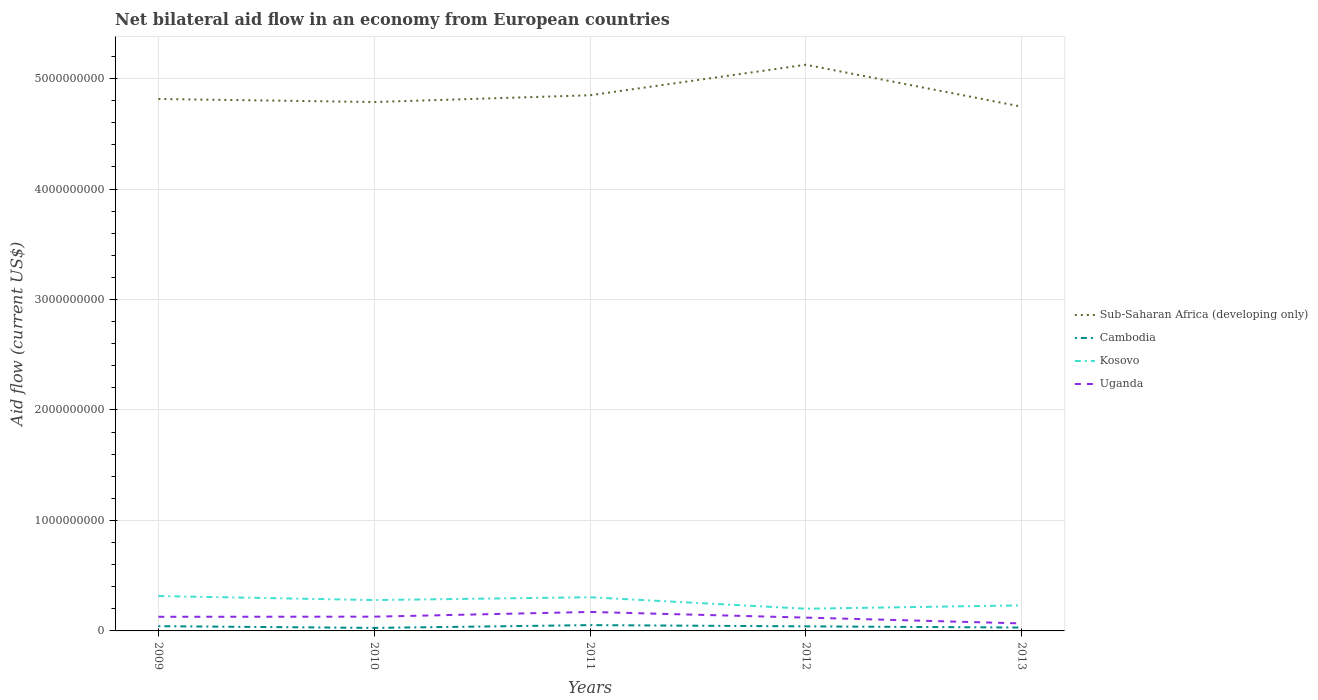Does the line corresponding to Sub-Saharan Africa (developing only) intersect with the line corresponding to Cambodia?
Your response must be concise. No. Across all years, what is the maximum net bilateral aid flow in Sub-Saharan Africa (developing only)?
Ensure brevity in your answer.  4.75e+09. In which year was the net bilateral aid flow in Uganda maximum?
Your response must be concise. 2013. What is the total net bilateral aid flow in Uganda in the graph?
Your answer should be compact. 1.04e+08. What is the difference between the highest and the second highest net bilateral aid flow in Uganda?
Provide a short and direct response. 1.04e+08. What is the difference between the highest and the lowest net bilateral aid flow in Kosovo?
Ensure brevity in your answer.  3. Is the net bilateral aid flow in Sub-Saharan Africa (developing only) strictly greater than the net bilateral aid flow in Kosovo over the years?
Your answer should be very brief. No. How many lines are there?
Your response must be concise. 4. What is the difference between two consecutive major ticks on the Y-axis?
Offer a terse response. 1.00e+09. Does the graph contain grids?
Ensure brevity in your answer.  Yes. Where does the legend appear in the graph?
Offer a terse response. Center right. How many legend labels are there?
Keep it short and to the point. 4. What is the title of the graph?
Your answer should be very brief. Net bilateral aid flow in an economy from European countries. What is the Aid flow (current US$) in Sub-Saharan Africa (developing only) in 2009?
Ensure brevity in your answer.  4.82e+09. What is the Aid flow (current US$) in Cambodia in 2009?
Your answer should be very brief. 4.31e+07. What is the Aid flow (current US$) in Kosovo in 2009?
Offer a terse response. 3.16e+08. What is the Aid flow (current US$) in Uganda in 2009?
Your answer should be very brief. 1.28e+08. What is the Aid flow (current US$) of Sub-Saharan Africa (developing only) in 2010?
Provide a succinct answer. 4.79e+09. What is the Aid flow (current US$) in Cambodia in 2010?
Your answer should be compact. 2.73e+07. What is the Aid flow (current US$) in Kosovo in 2010?
Your response must be concise. 2.79e+08. What is the Aid flow (current US$) in Uganda in 2010?
Keep it short and to the point. 1.29e+08. What is the Aid flow (current US$) in Sub-Saharan Africa (developing only) in 2011?
Your answer should be very brief. 4.85e+09. What is the Aid flow (current US$) of Cambodia in 2011?
Provide a succinct answer. 5.26e+07. What is the Aid flow (current US$) in Kosovo in 2011?
Offer a very short reply. 3.05e+08. What is the Aid flow (current US$) of Uganda in 2011?
Keep it short and to the point. 1.72e+08. What is the Aid flow (current US$) in Sub-Saharan Africa (developing only) in 2012?
Make the answer very short. 5.13e+09. What is the Aid flow (current US$) of Cambodia in 2012?
Your response must be concise. 4.14e+07. What is the Aid flow (current US$) of Kosovo in 2012?
Provide a succinct answer. 2.01e+08. What is the Aid flow (current US$) in Uganda in 2012?
Give a very brief answer. 1.21e+08. What is the Aid flow (current US$) in Sub-Saharan Africa (developing only) in 2013?
Offer a terse response. 4.75e+09. What is the Aid flow (current US$) of Cambodia in 2013?
Ensure brevity in your answer.  3.06e+07. What is the Aid flow (current US$) of Kosovo in 2013?
Your answer should be very brief. 2.31e+08. What is the Aid flow (current US$) of Uganda in 2013?
Provide a succinct answer. 6.80e+07. Across all years, what is the maximum Aid flow (current US$) in Sub-Saharan Africa (developing only)?
Offer a very short reply. 5.13e+09. Across all years, what is the maximum Aid flow (current US$) in Cambodia?
Make the answer very short. 5.26e+07. Across all years, what is the maximum Aid flow (current US$) in Kosovo?
Give a very brief answer. 3.16e+08. Across all years, what is the maximum Aid flow (current US$) of Uganda?
Give a very brief answer. 1.72e+08. Across all years, what is the minimum Aid flow (current US$) in Sub-Saharan Africa (developing only)?
Make the answer very short. 4.75e+09. Across all years, what is the minimum Aid flow (current US$) in Cambodia?
Offer a very short reply. 2.73e+07. Across all years, what is the minimum Aid flow (current US$) in Kosovo?
Offer a very short reply. 2.01e+08. Across all years, what is the minimum Aid flow (current US$) of Uganda?
Offer a very short reply. 6.80e+07. What is the total Aid flow (current US$) of Sub-Saharan Africa (developing only) in the graph?
Give a very brief answer. 2.43e+1. What is the total Aid flow (current US$) of Cambodia in the graph?
Your response must be concise. 1.95e+08. What is the total Aid flow (current US$) of Kosovo in the graph?
Keep it short and to the point. 1.33e+09. What is the total Aid flow (current US$) in Uganda in the graph?
Give a very brief answer. 6.17e+08. What is the difference between the Aid flow (current US$) in Sub-Saharan Africa (developing only) in 2009 and that in 2010?
Provide a succinct answer. 2.76e+07. What is the difference between the Aid flow (current US$) of Cambodia in 2009 and that in 2010?
Offer a terse response. 1.58e+07. What is the difference between the Aid flow (current US$) of Kosovo in 2009 and that in 2010?
Your response must be concise. 3.66e+07. What is the difference between the Aid flow (current US$) in Uganda in 2009 and that in 2010?
Your response must be concise. -9.00e+05. What is the difference between the Aid flow (current US$) in Sub-Saharan Africa (developing only) in 2009 and that in 2011?
Your answer should be very brief. -3.36e+07. What is the difference between the Aid flow (current US$) of Cambodia in 2009 and that in 2011?
Keep it short and to the point. -9.47e+06. What is the difference between the Aid flow (current US$) in Kosovo in 2009 and that in 2011?
Offer a terse response. 1.11e+07. What is the difference between the Aid flow (current US$) of Uganda in 2009 and that in 2011?
Your answer should be very brief. -4.37e+07. What is the difference between the Aid flow (current US$) of Sub-Saharan Africa (developing only) in 2009 and that in 2012?
Give a very brief answer. -3.10e+08. What is the difference between the Aid flow (current US$) in Cambodia in 2009 and that in 2012?
Provide a short and direct response. 1.69e+06. What is the difference between the Aid flow (current US$) in Kosovo in 2009 and that in 2012?
Ensure brevity in your answer.  1.15e+08. What is the difference between the Aid flow (current US$) in Uganda in 2009 and that in 2012?
Your answer should be compact. 7.44e+06. What is the difference between the Aid flow (current US$) of Sub-Saharan Africa (developing only) in 2009 and that in 2013?
Keep it short and to the point. 6.98e+07. What is the difference between the Aid flow (current US$) in Cambodia in 2009 and that in 2013?
Provide a succinct answer. 1.25e+07. What is the difference between the Aid flow (current US$) in Kosovo in 2009 and that in 2013?
Offer a terse response. 8.45e+07. What is the difference between the Aid flow (current US$) in Uganda in 2009 and that in 2013?
Provide a succinct answer. 6.01e+07. What is the difference between the Aid flow (current US$) in Sub-Saharan Africa (developing only) in 2010 and that in 2011?
Give a very brief answer. -6.11e+07. What is the difference between the Aid flow (current US$) of Cambodia in 2010 and that in 2011?
Make the answer very short. -2.52e+07. What is the difference between the Aid flow (current US$) in Kosovo in 2010 and that in 2011?
Offer a very short reply. -2.55e+07. What is the difference between the Aid flow (current US$) in Uganda in 2010 and that in 2011?
Make the answer very short. -4.28e+07. What is the difference between the Aid flow (current US$) in Sub-Saharan Africa (developing only) in 2010 and that in 2012?
Your answer should be very brief. -3.38e+08. What is the difference between the Aid flow (current US$) in Cambodia in 2010 and that in 2012?
Give a very brief answer. -1.41e+07. What is the difference between the Aid flow (current US$) in Kosovo in 2010 and that in 2012?
Provide a succinct answer. 7.84e+07. What is the difference between the Aid flow (current US$) in Uganda in 2010 and that in 2012?
Provide a succinct answer. 8.34e+06. What is the difference between the Aid flow (current US$) in Sub-Saharan Africa (developing only) in 2010 and that in 2013?
Provide a short and direct response. 4.22e+07. What is the difference between the Aid flow (current US$) in Cambodia in 2010 and that in 2013?
Make the answer very short. -3.26e+06. What is the difference between the Aid flow (current US$) in Kosovo in 2010 and that in 2013?
Offer a terse response. 4.79e+07. What is the difference between the Aid flow (current US$) of Uganda in 2010 and that in 2013?
Ensure brevity in your answer.  6.10e+07. What is the difference between the Aid flow (current US$) in Sub-Saharan Africa (developing only) in 2011 and that in 2012?
Provide a short and direct response. -2.76e+08. What is the difference between the Aid flow (current US$) in Cambodia in 2011 and that in 2012?
Make the answer very short. 1.12e+07. What is the difference between the Aid flow (current US$) of Kosovo in 2011 and that in 2012?
Ensure brevity in your answer.  1.04e+08. What is the difference between the Aid flow (current US$) in Uganda in 2011 and that in 2012?
Your answer should be very brief. 5.12e+07. What is the difference between the Aid flow (current US$) of Sub-Saharan Africa (developing only) in 2011 and that in 2013?
Ensure brevity in your answer.  1.03e+08. What is the difference between the Aid flow (current US$) of Cambodia in 2011 and that in 2013?
Your answer should be compact. 2.20e+07. What is the difference between the Aid flow (current US$) in Kosovo in 2011 and that in 2013?
Ensure brevity in your answer.  7.34e+07. What is the difference between the Aid flow (current US$) in Uganda in 2011 and that in 2013?
Provide a succinct answer. 1.04e+08. What is the difference between the Aid flow (current US$) of Sub-Saharan Africa (developing only) in 2012 and that in 2013?
Offer a terse response. 3.80e+08. What is the difference between the Aid flow (current US$) in Cambodia in 2012 and that in 2013?
Give a very brief answer. 1.08e+07. What is the difference between the Aid flow (current US$) in Kosovo in 2012 and that in 2013?
Your answer should be compact. -3.04e+07. What is the difference between the Aid flow (current US$) in Uganda in 2012 and that in 2013?
Give a very brief answer. 5.26e+07. What is the difference between the Aid flow (current US$) in Sub-Saharan Africa (developing only) in 2009 and the Aid flow (current US$) in Cambodia in 2010?
Your response must be concise. 4.79e+09. What is the difference between the Aid flow (current US$) of Sub-Saharan Africa (developing only) in 2009 and the Aid flow (current US$) of Kosovo in 2010?
Give a very brief answer. 4.54e+09. What is the difference between the Aid flow (current US$) in Sub-Saharan Africa (developing only) in 2009 and the Aid flow (current US$) in Uganda in 2010?
Offer a very short reply. 4.69e+09. What is the difference between the Aid flow (current US$) of Cambodia in 2009 and the Aid flow (current US$) of Kosovo in 2010?
Provide a short and direct response. -2.36e+08. What is the difference between the Aid flow (current US$) in Cambodia in 2009 and the Aid flow (current US$) in Uganda in 2010?
Make the answer very short. -8.59e+07. What is the difference between the Aid flow (current US$) in Kosovo in 2009 and the Aid flow (current US$) in Uganda in 2010?
Give a very brief answer. 1.87e+08. What is the difference between the Aid flow (current US$) in Sub-Saharan Africa (developing only) in 2009 and the Aid flow (current US$) in Cambodia in 2011?
Ensure brevity in your answer.  4.76e+09. What is the difference between the Aid flow (current US$) of Sub-Saharan Africa (developing only) in 2009 and the Aid flow (current US$) of Kosovo in 2011?
Your answer should be very brief. 4.51e+09. What is the difference between the Aid flow (current US$) in Sub-Saharan Africa (developing only) in 2009 and the Aid flow (current US$) in Uganda in 2011?
Offer a terse response. 4.64e+09. What is the difference between the Aid flow (current US$) in Cambodia in 2009 and the Aid flow (current US$) in Kosovo in 2011?
Your response must be concise. -2.62e+08. What is the difference between the Aid flow (current US$) in Cambodia in 2009 and the Aid flow (current US$) in Uganda in 2011?
Keep it short and to the point. -1.29e+08. What is the difference between the Aid flow (current US$) in Kosovo in 2009 and the Aid flow (current US$) in Uganda in 2011?
Provide a succinct answer. 1.44e+08. What is the difference between the Aid flow (current US$) of Sub-Saharan Africa (developing only) in 2009 and the Aid flow (current US$) of Cambodia in 2012?
Offer a very short reply. 4.77e+09. What is the difference between the Aid flow (current US$) of Sub-Saharan Africa (developing only) in 2009 and the Aid flow (current US$) of Kosovo in 2012?
Offer a terse response. 4.61e+09. What is the difference between the Aid flow (current US$) of Sub-Saharan Africa (developing only) in 2009 and the Aid flow (current US$) of Uganda in 2012?
Offer a very short reply. 4.69e+09. What is the difference between the Aid flow (current US$) of Cambodia in 2009 and the Aid flow (current US$) of Kosovo in 2012?
Provide a short and direct response. -1.58e+08. What is the difference between the Aid flow (current US$) of Cambodia in 2009 and the Aid flow (current US$) of Uganda in 2012?
Provide a short and direct response. -7.75e+07. What is the difference between the Aid flow (current US$) of Kosovo in 2009 and the Aid flow (current US$) of Uganda in 2012?
Your response must be concise. 1.95e+08. What is the difference between the Aid flow (current US$) in Sub-Saharan Africa (developing only) in 2009 and the Aid flow (current US$) in Cambodia in 2013?
Keep it short and to the point. 4.78e+09. What is the difference between the Aid flow (current US$) in Sub-Saharan Africa (developing only) in 2009 and the Aid flow (current US$) in Kosovo in 2013?
Ensure brevity in your answer.  4.58e+09. What is the difference between the Aid flow (current US$) in Sub-Saharan Africa (developing only) in 2009 and the Aid flow (current US$) in Uganda in 2013?
Keep it short and to the point. 4.75e+09. What is the difference between the Aid flow (current US$) of Cambodia in 2009 and the Aid flow (current US$) of Kosovo in 2013?
Ensure brevity in your answer.  -1.88e+08. What is the difference between the Aid flow (current US$) in Cambodia in 2009 and the Aid flow (current US$) in Uganda in 2013?
Your answer should be compact. -2.49e+07. What is the difference between the Aid flow (current US$) in Kosovo in 2009 and the Aid flow (current US$) in Uganda in 2013?
Your answer should be compact. 2.48e+08. What is the difference between the Aid flow (current US$) in Sub-Saharan Africa (developing only) in 2010 and the Aid flow (current US$) in Cambodia in 2011?
Provide a succinct answer. 4.74e+09. What is the difference between the Aid flow (current US$) of Sub-Saharan Africa (developing only) in 2010 and the Aid flow (current US$) of Kosovo in 2011?
Keep it short and to the point. 4.48e+09. What is the difference between the Aid flow (current US$) in Sub-Saharan Africa (developing only) in 2010 and the Aid flow (current US$) in Uganda in 2011?
Ensure brevity in your answer.  4.62e+09. What is the difference between the Aid flow (current US$) in Cambodia in 2010 and the Aid flow (current US$) in Kosovo in 2011?
Give a very brief answer. -2.78e+08. What is the difference between the Aid flow (current US$) of Cambodia in 2010 and the Aid flow (current US$) of Uganda in 2011?
Give a very brief answer. -1.44e+08. What is the difference between the Aid flow (current US$) of Kosovo in 2010 and the Aid flow (current US$) of Uganda in 2011?
Give a very brief answer. 1.08e+08. What is the difference between the Aid flow (current US$) of Sub-Saharan Africa (developing only) in 2010 and the Aid flow (current US$) of Cambodia in 2012?
Your answer should be very brief. 4.75e+09. What is the difference between the Aid flow (current US$) of Sub-Saharan Africa (developing only) in 2010 and the Aid flow (current US$) of Kosovo in 2012?
Your answer should be compact. 4.59e+09. What is the difference between the Aid flow (current US$) in Sub-Saharan Africa (developing only) in 2010 and the Aid flow (current US$) in Uganda in 2012?
Your response must be concise. 4.67e+09. What is the difference between the Aid flow (current US$) of Cambodia in 2010 and the Aid flow (current US$) of Kosovo in 2012?
Make the answer very short. -1.74e+08. What is the difference between the Aid flow (current US$) in Cambodia in 2010 and the Aid flow (current US$) in Uganda in 2012?
Your answer should be compact. -9.33e+07. What is the difference between the Aid flow (current US$) in Kosovo in 2010 and the Aid flow (current US$) in Uganda in 2012?
Provide a succinct answer. 1.59e+08. What is the difference between the Aid flow (current US$) in Sub-Saharan Africa (developing only) in 2010 and the Aid flow (current US$) in Cambodia in 2013?
Give a very brief answer. 4.76e+09. What is the difference between the Aid flow (current US$) in Sub-Saharan Africa (developing only) in 2010 and the Aid flow (current US$) in Kosovo in 2013?
Your response must be concise. 4.56e+09. What is the difference between the Aid flow (current US$) of Sub-Saharan Africa (developing only) in 2010 and the Aid flow (current US$) of Uganda in 2013?
Keep it short and to the point. 4.72e+09. What is the difference between the Aid flow (current US$) of Cambodia in 2010 and the Aid flow (current US$) of Kosovo in 2013?
Offer a terse response. -2.04e+08. What is the difference between the Aid flow (current US$) in Cambodia in 2010 and the Aid flow (current US$) in Uganda in 2013?
Your answer should be compact. -4.06e+07. What is the difference between the Aid flow (current US$) of Kosovo in 2010 and the Aid flow (current US$) of Uganda in 2013?
Make the answer very short. 2.11e+08. What is the difference between the Aid flow (current US$) of Sub-Saharan Africa (developing only) in 2011 and the Aid flow (current US$) of Cambodia in 2012?
Keep it short and to the point. 4.81e+09. What is the difference between the Aid flow (current US$) in Sub-Saharan Africa (developing only) in 2011 and the Aid flow (current US$) in Kosovo in 2012?
Your answer should be compact. 4.65e+09. What is the difference between the Aid flow (current US$) of Sub-Saharan Africa (developing only) in 2011 and the Aid flow (current US$) of Uganda in 2012?
Provide a short and direct response. 4.73e+09. What is the difference between the Aid flow (current US$) in Cambodia in 2011 and the Aid flow (current US$) in Kosovo in 2012?
Offer a terse response. -1.48e+08. What is the difference between the Aid flow (current US$) of Cambodia in 2011 and the Aid flow (current US$) of Uganda in 2012?
Make the answer very short. -6.80e+07. What is the difference between the Aid flow (current US$) in Kosovo in 2011 and the Aid flow (current US$) in Uganda in 2012?
Ensure brevity in your answer.  1.84e+08. What is the difference between the Aid flow (current US$) of Sub-Saharan Africa (developing only) in 2011 and the Aid flow (current US$) of Cambodia in 2013?
Provide a short and direct response. 4.82e+09. What is the difference between the Aid flow (current US$) in Sub-Saharan Africa (developing only) in 2011 and the Aid flow (current US$) in Kosovo in 2013?
Offer a terse response. 4.62e+09. What is the difference between the Aid flow (current US$) of Sub-Saharan Africa (developing only) in 2011 and the Aid flow (current US$) of Uganda in 2013?
Ensure brevity in your answer.  4.78e+09. What is the difference between the Aid flow (current US$) in Cambodia in 2011 and the Aid flow (current US$) in Kosovo in 2013?
Your response must be concise. -1.79e+08. What is the difference between the Aid flow (current US$) of Cambodia in 2011 and the Aid flow (current US$) of Uganda in 2013?
Provide a succinct answer. -1.54e+07. What is the difference between the Aid flow (current US$) of Kosovo in 2011 and the Aid flow (current US$) of Uganda in 2013?
Make the answer very short. 2.37e+08. What is the difference between the Aid flow (current US$) of Sub-Saharan Africa (developing only) in 2012 and the Aid flow (current US$) of Cambodia in 2013?
Keep it short and to the point. 5.09e+09. What is the difference between the Aid flow (current US$) of Sub-Saharan Africa (developing only) in 2012 and the Aid flow (current US$) of Kosovo in 2013?
Provide a succinct answer. 4.89e+09. What is the difference between the Aid flow (current US$) of Sub-Saharan Africa (developing only) in 2012 and the Aid flow (current US$) of Uganda in 2013?
Provide a short and direct response. 5.06e+09. What is the difference between the Aid flow (current US$) of Cambodia in 2012 and the Aid flow (current US$) of Kosovo in 2013?
Give a very brief answer. -1.90e+08. What is the difference between the Aid flow (current US$) of Cambodia in 2012 and the Aid flow (current US$) of Uganda in 2013?
Provide a short and direct response. -2.66e+07. What is the difference between the Aid flow (current US$) in Kosovo in 2012 and the Aid flow (current US$) in Uganda in 2013?
Ensure brevity in your answer.  1.33e+08. What is the average Aid flow (current US$) of Sub-Saharan Africa (developing only) per year?
Keep it short and to the point. 4.86e+09. What is the average Aid flow (current US$) in Cambodia per year?
Keep it short and to the point. 3.90e+07. What is the average Aid flow (current US$) of Kosovo per year?
Offer a terse response. 2.66e+08. What is the average Aid flow (current US$) in Uganda per year?
Give a very brief answer. 1.23e+08. In the year 2009, what is the difference between the Aid flow (current US$) of Sub-Saharan Africa (developing only) and Aid flow (current US$) of Cambodia?
Ensure brevity in your answer.  4.77e+09. In the year 2009, what is the difference between the Aid flow (current US$) in Sub-Saharan Africa (developing only) and Aid flow (current US$) in Kosovo?
Provide a succinct answer. 4.50e+09. In the year 2009, what is the difference between the Aid flow (current US$) of Sub-Saharan Africa (developing only) and Aid flow (current US$) of Uganda?
Give a very brief answer. 4.69e+09. In the year 2009, what is the difference between the Aid flow (current US$) of Cambodia and Aid flow (current US$) of Kosovo?
Ensure brevity in your answer.  -2.73e+08. In the year 2009, what is the difference between the Aid flow (current US$) in Cambodia and Aid flow (current US$) in Uganda?
Provide a succinct answer. -8.50e+07. In the year 2009, what is the difference between the Aid flow (current US$) of Kosovo and Aid flow (current US$) of Uganda?
Provide a short and direct response. 1.88e+08. In the year 2010, what is the difference between the Aid flow (current US$) of Sub-Saharan Africa (developing only) and Aid flow (current US$) of Cambodia?
Offer a terse response. 4.76e+09. In the year 2010, what is the difference between the Aid flow (current US$) of Sub-Saharan Africa (developing only) and Aid flow (current US$) of Kosovo?
Provide a succinct answer. 4.51e+09. In the year 2010, what is the difference between the Aid flow (current US$) in Sub-Saharan Africa (developing only) and Aid flow (current US$) in Uganda?
Your response must be concise. 4.66e+09. In the year 2010, what is the difference between the Aid flow (current US$) of Cambodia and Aid flow (current US$) of Kosovo?
Give a very brief answer. -2.52e+08. In the year 2010, what is the difference between the Aid flow (current US$) of Cambodia and Aid flow (current US$) of Uganda?
Make the answer very short. -1.02e+08. In the year 2010, what is the difference between the Aid flow (current US$) of Kosovo and Aid flow (current US$) of Uganda?
Keep it short and to the point. 1.50e+08. In the year 2011, what is the difference between the Aid flow (current US$) in Sub-Saharan Africa (developing only) and Aid flow (current US$) in Cambodia?
Offer a terse response. 4.80e+09. In the year 2011, what is the difference between the Aid flow (current US$) in Sub-Saharan Africa (developing only) and Aid flow (current US$) in Kosovo?
Your answer should be compact. 4.54e+09. In the year 2011, what is the difference between the Aid flow (current US$) of Sub-Saharan Africa (developing only) and Aid flow (current US$) of Uganda?
Offer a terse response. 4.68e+09. In the year 2011, what is the difference between the Aid flow (current US$) of Cambodia and Aid flow (current US$) of Kosovo?
Offer a very short reply. -2.52e+08. In the year 2011, what is the difference between the Aid flow (current US$) of Cambodia and Aid flow (current US$) of Uganda?
Give a very brief answer. -1.19e+08. In the year 2011, what is the difference between the Aid flow (current US$) of Kosovo and Aid flow (current US$) of Uganda?
Your answer should be compact. 1.33e+08. In the year 2012, what is the difference between the Aid flow (current US$) in Sub-Saharan Africa (developing only) and Aid flow (current US$) in Cambodia?
Your answer should be very brief. 5.08e+09. In the year 2012, what is the difference between the Aid flow (current US$) of Sub-Saharan Africa (developing only) and Aid flow (current US$) of Kosovo?
Ensure brevity in your answer.  4.92e+09. In the year 2012, what is the difference between the Aid flow (current US$) of Sub-Saharan Africa (developing only) and Aid flow (current US$) of Uganda?
Offer a very short reply. 5.00e+09. In the year 2012, what is the difference between the Aid flow (current US$) in Cambodia and Aid flow (current US$) in Kosovo?
Your response must be concise. -1.60e+08. In the year 2012, what is the difference between the Aid flow (current US$) of Cambodia and Aid flow (current US$) of Uganda?
Offer a terse response. -7.92e+07. In the year 2012, what is the difference between the Aid flow (current US$) of Kosovo and Aid flow (current US$) of Uganda?
Give a very brief answer. 8.04e+07. In the year 2013, what is the difference between the Aid flow (current US$) of Sub-Saharan Africa (developing only) and Aid flow (current US$) of Cambodia?
Ensure brevity in your answer.  4.72e+09. In the year 2013, what is the difference between the Aid flow (current US$) of Sub-Saharan Africa (developing only) and Aid flow (current US$) of Kosovo?
Your response must be concise. 4.51e+09. In the year 2013, what is the difference between the Aid flow (current US$) in Sub-Saharan Africa (developing only) and Aid flow (current US$) in Uganda?
Your answer should be very brief. 4.68e+09. In the year 2013, what is the difference between the Aid flow (current US$) in Cambodia and Aid flow (current US$) in Kosovo?
Your response must be concise. -2.01e+08. In the year 2013, what is the difference between the Aid flow (current US$) in Cambodia and Aid flow (current US$) in Uganda?
Your answer should be very brief. -3.74e+07. In the year 2013, what is the difference between the Aid flow (current US$) in Kosovo and Aid flow (current US$) in Uganda?
Your answer should be very brief. 1.63e+08. What is the ratio of the Aid flow (current US$) of Cambodia in 2009 to that in 2010?
Offer a very short reply. 1.58. What is the ratio of the Aid flow (current US$) in Kosovo in 2009 to that in 2010?
Offer a very short reply. 1.13. What is the ratio of the Aid flow (current US$) in Uganda in 2009 to that in 2010?
Your answer should be very brief. 0.99. What is the ratio of the Aid flow (current US$) of Sub-Saharan Africa (developing only) in 2009 to that in 2011?
Your answer should be compact. 0.99. What is the ratio of the Aid flow (current US$) of Cambodia in 2009 to that in 2011?
Offer a very short reply. 0.82. What is the ratio of the Aid flow (current US$) of Kosovo in 2009 to that in 2011?
Ensure brevity in your answer.  1.04. What is the ratio of the Aid flow (current US$) in Uganda in 2009 to that in 2011?
Keep it short and to the point. 0.75. What is the ratio of the Aid flow (current US$) in Sub-Saharan Africa (developing only) in 2009 to that in 2012?
Keep it short and to the point. 0.94. What is the ratio of the Aid flow (current US$) in Cambodia in 2009 to that in 2012?
Give a very brief answer. 1.04. What is the ratio of the Aid flow (current US$) in Kosovo in 2009 to that in 2012?
Your answer should be very brief. 1.57. What is the ratio of the Aid flow (current US$) of Uganda in 2009 to that in 2012?
Ensure brevity in your answer.  1.06. What is the ratio of the Aid flow (current US$) in Sub-Saharan Africa (developing only) in 2009 to that in 2013?
Provide a short and direct response. 1.01. What is the ratio of the Aid flow (current US$) of Cambodia in 2009 to that in 2013?
Provide a short and direct response. 1.41. What is the ratio of the Aid flow (current US$) in Kosovo in 2009 to that in 2013?
Offer a terse response. 1.37. What is the ratio of the Aid flow (current US$) of Uganda in 2009 to that in 2013?
Ensure brevity in your answer.  1.88. What is the ratio of the Aid flow (current US$) in Sub-Saharan Africa (developing only) in 2010 to that in 2011?
Ensure brevity in your answer.  0.99. What is the ratio of the Aid flow (current US$) of Cambodia in 2010 to that in 2011?
Offer a very short reply. 0.52. What is the ratio of the Aid flow (current US$) of Kosovo in 2010 to that in 2011?
Your response must be concise. 0.92. What is the ratio of the Aid flow (current US$) in Uganda in 2010 to that in 2011?
Ensure brevity in your answer.  0.75. What is the ratio of the Aid flow (current US$) in Sub-Saharan Africa (developing only) in 2010 to that in 2012?
Give a very brief answer. 0.93. What is the ratio of the Aid flow (current US$) of Cambodia in 2010 to that in 2012?
Offer a very short reply. 0.66. What is the ratio of the Aid flow (current US$) in Kosovo in 2010 to that in 2012?
Keep it short and to the point. 1.39. What is the ratio of the Aid flow (current US$) of Uganda in 2010 to that in 2012?
Provide a succinct answer. 1.07. What is the ratio of the Aid flow (current US$) of Sub-Saharan Africa (developing only) in 2010 to that in 2013?
Make the answer very short. 1.01. What is the ratio of the Aid flow (current US$) of Cambodia in 2010 to that in 2013?
Give a very brief answer. 0.89. What is the ratio of the Aid flow (current US$) in Kosovo in 2010 to that in 2013?
Provide a succinct answer. 1.21. What is the ratio of the Aid flow (current US$) of Uganda in 2010 to that in 2013?
Ensure brevity in your answer.  1.9. What is the ratio of the Aid flow (current US$) of Sub-Saharan Africa (developing only) in 2011 to that in 2012?
Provide a succinct answer. 0.95. What is the ratio of the Aid flow (current US$) of Cambodia in 2011 to that in 2012?
Make the answer very short. 1.27. What is the ratio of the Aid flow (current US$) of Kosovo in 2011 to that in 2012?
Offer a very short reply. 1.52. What is the ratio of the Aid flow (current US$) of Uganda in 2011 to that in 2012?
Provide a short and direct response. 1.42. What is the ratio of the Aid flow (current US$) in Sub-Saharan Africa (developing only) in 2011 to that in 2013?
Your answer should be compact. 1.02. What is the ratio of the Aid flow (current US$) in Cambodia in 2011 to that in 2013?
Your answer should be compact. 1.72. What is the ratio of the Aid flow (current US$) in Kosovo in 2011 to that in 2013?
Offer a terse response. 1.32. What is the ratio of the Aid flow (current US$) in Uganda in 2011 to that in 2013?
Offer a very short reply. 2.53. What is the ratio of the Aid flow (current US$) of Cambodia in 2012 to that in 2013?
Keep it short and to the point. 1.35. What is the ratio of the Aid flow (current US$) of Kosovo in 2012 to that in 2013?
Your answer should be very brief. 0.87. What is the ratio of the Aid flow (current US$) in Uganda in 2012 to that in 2013?
Your response must be concise. 1.77. What is the difference between the highest and the second highest Aid flow (current US$) in Sub-Saharan Africa (developing only)?
Make the answer very short. 2.76e+08. What is the difference between the highest and the second highest Aid flow (current US$) in Cambodia?
Make the answer very short. 9.47e+06. What is the difference between the highest and the second highest Aid flow (current US$) in Kosovo?
Ensure brevity in your answer.  1.11e+07. What is the difference between the highest and the second highest Aid flow (current US$) of Uganda?
Give a very brief answer. 4.28e+07. What is the difference between the highest and the lowest Aid flow (current US$) in Sub-Saharan Africa (developing only)?
Make the answer very short. 3.80e+08. What is the difference between the highest and the lowest Aid flow (current US$) of Cambodia?
Ensure brevity in your answer.  2.52e+07. What is the difference between the highest and the lowest Aid flow (current US$) of Kosovo?
Your answer should be very brief. 1.15e+08. What is the difference between the highest and the lowest Aid flow (current US$) of Uganda?
Your answer should be compact. 1.04e+08. 